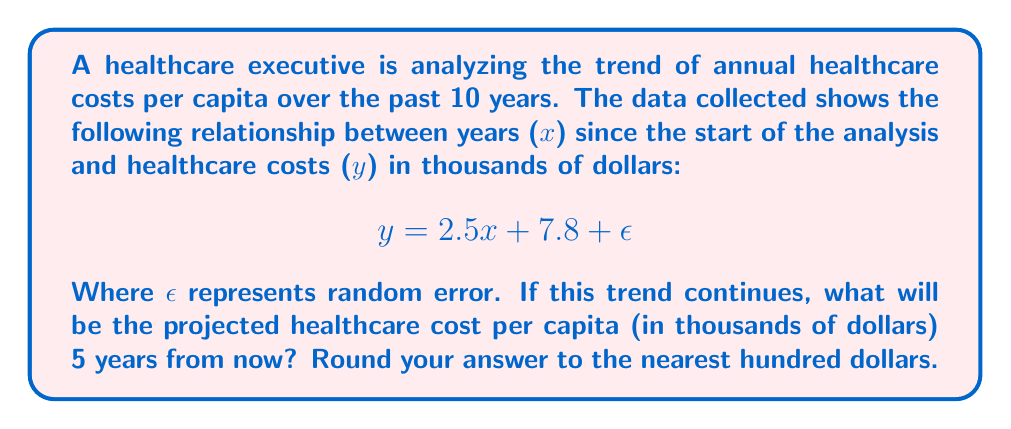Can you solve this math problem? To solve this problem, we need to use the given regression equation and extrapolate to predict the future healthcare cost. Let's break it down step-by-step:

1. The regression equation is given as:
   $$y = 2.5x + 7.8 + \epsilon$$

2. In this equation:
   - $y$ represents the healthcare cost in thousands of dollars
   - $x$ represents the number of years since the start of the analysis
   - $2.5$ is the slope, indicating that costs increase by $2,500 per year
   - $7.8$ is the y-intercept, representing the initial cost at the start of the analysis
   - $\epsilon$ represents random error, which we can ignore for prediction purposes

3. We want to predict the cost 5 years from now. Since the analysis covers the past 10 years, the value of $x$ for our prediction will be $15$ (10 + 5).

4. Let's substitute $x = 15$ into the equation:
   $$y = 2.5(15) + 7.8$$

5. Simplify:
   $$y = 37.5 + 7.8 = 45.3$$

6. This result is in thousands of dollars. To convert to dollars, multiply by 1000:
   $$45.3 * 1000 = 45,300$$

7. Rounding to the nearest hundred dollars:
   $$45,300 \approx 45,300$$

Therefore, the projected healthcare cost per capita 5 years from now will be $45,300.
Answer: $45,300 